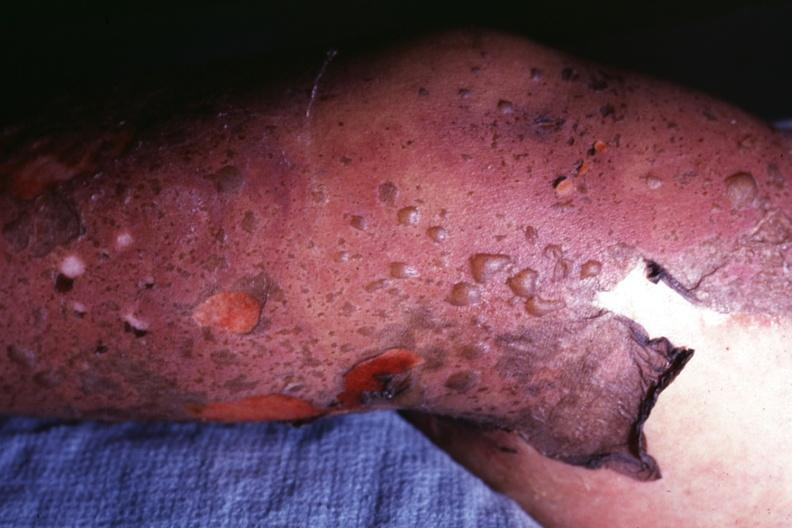what is present?
Answer the question using a single word or phrase. Toxic epidermal necrolysis 